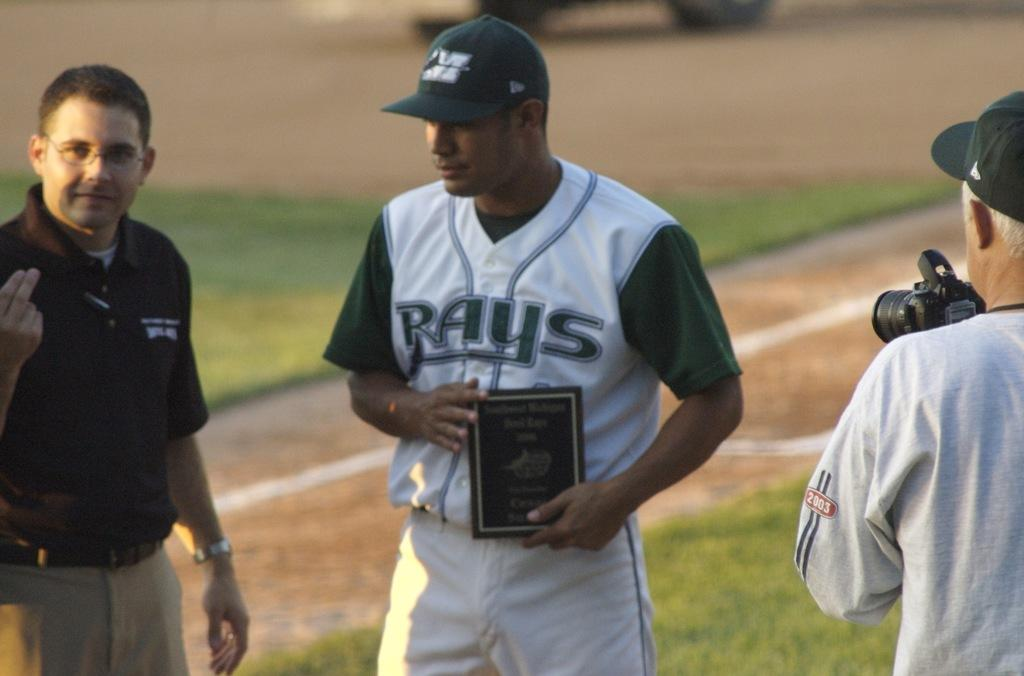<image>
Provide a brief description of the given image. a player with a Rays jersey on themselves 